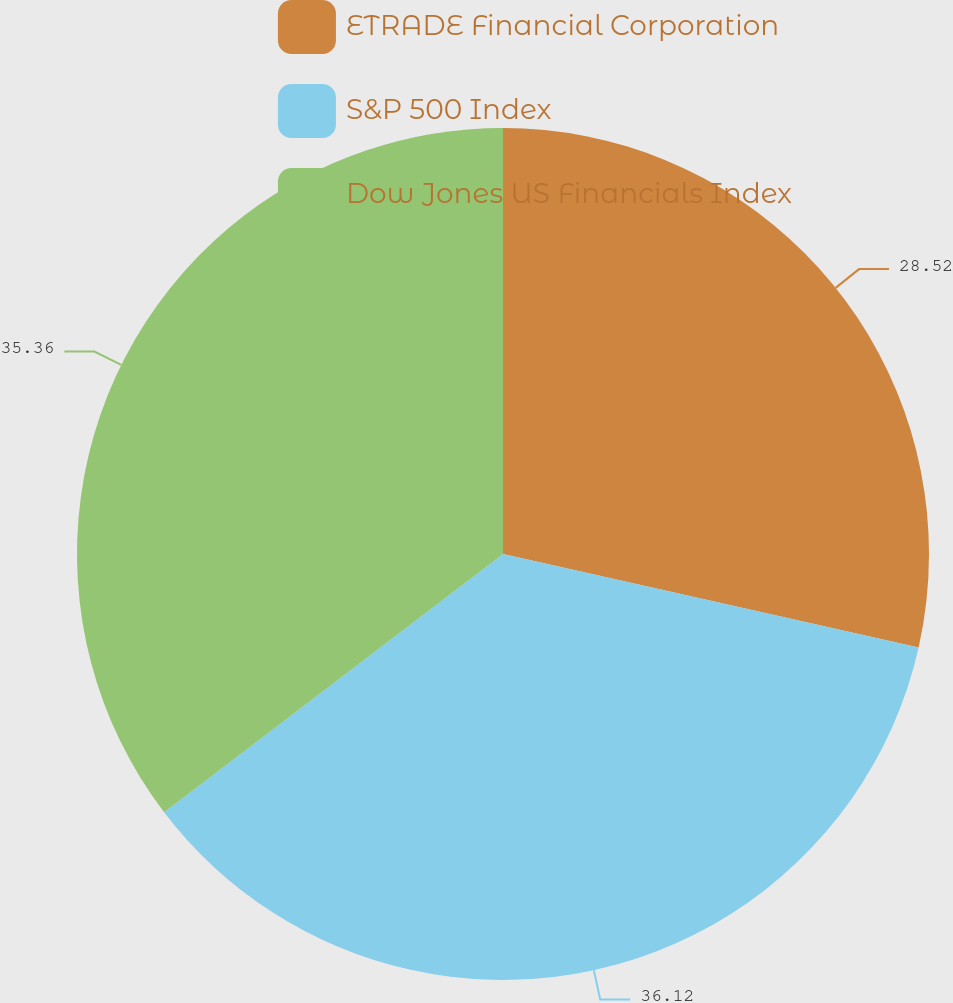Convert chart. <chart><loc_0><loc_0><loc_500><loc_500><pie_chart><fcel>ETRADE Financial Corporation<fcel>S&P 500 Index<fcel>Dow Jones US Financials Index<nl><fcel>28.52%<fcel>36.12%<fcel>35.36%<nl></chart> 